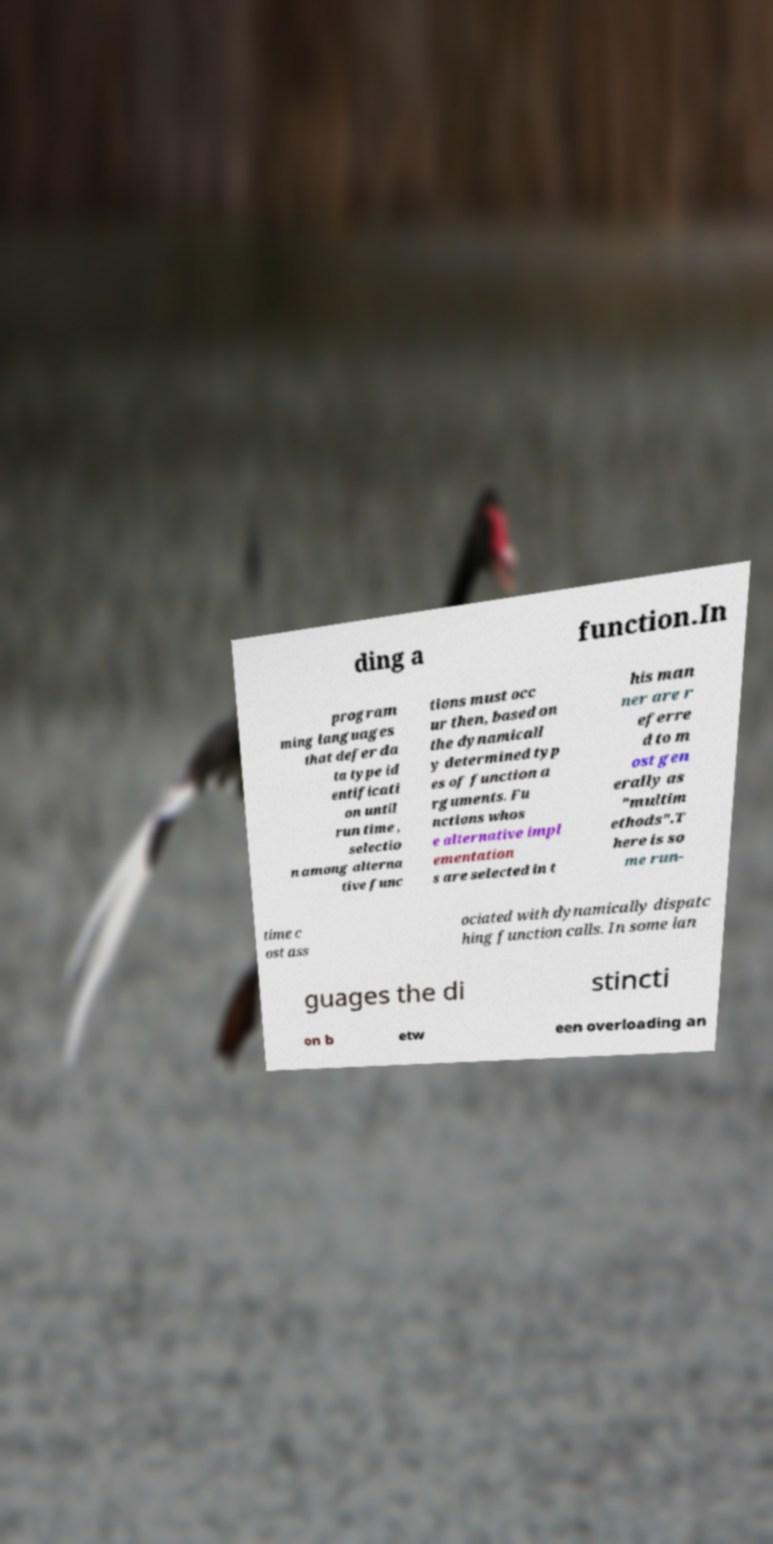What messages or text are displayed in this image? I need them in a readable, typed format. ding a function.In program ming languages that defer da ta type id entificati on until run time , selectio n among alterna tive func tions must occ ur then, based on the dynamicall y determined typ es of function a rguments. Fu nctions whos e alternative impl ementation s are selected in t his man ner are r eferre d to m ost gen erally as "multim ethods".T here is so me run- time c ost ass ociated with dynamically dispatc hing function calls. In some lan guages the di stincti on b etw een overloading an 